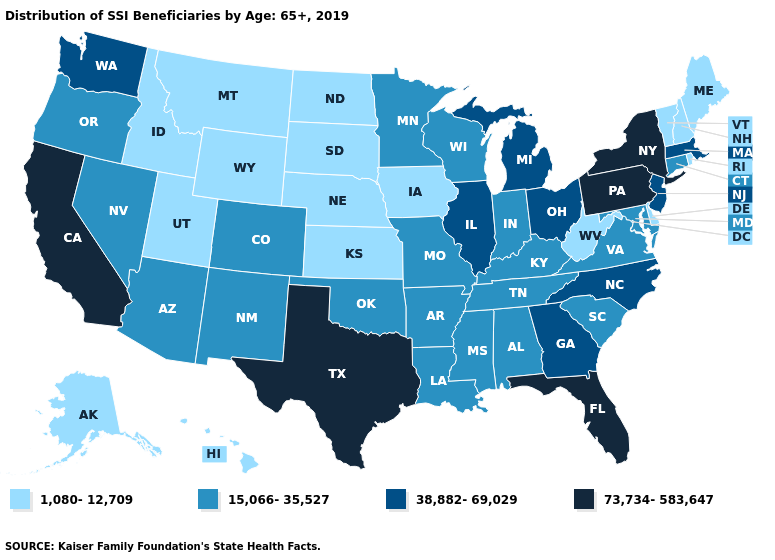Name the states that have a value in the range 38,882-69,029?
Short answer required. Georgia, Illinois, Massachusetts, Michigan, New Jersey, North Carolina, Ohio, Washington. Does the map have missing data?
Concise answer only. No. What is the value of Oregon?
Keep it brief. 15,066-35,527. Name the states that have a value in the range 1,080-12,709?
Write a very short answer. Alaska, Delaware, Hawaii, Idaho, Iowa, Kansas, Maine, Montana, Nebraska, New Hampshire, North Dakota, Rhode Island, South Dakota, Utah, Vermont, West Virginia, Wyoming. Does Wyoming have the same value as Iowa?
Answer briefly. Yes. Does the first symbol in the legend represent the smallest category?
Concise answer only. Yes. Does South Dakota have a lower value than Louisiana?
Quick response, please. Yes. What is the value of Massachusetts?
Give a very brief answer. 38,882-69,029. What is the value of Indiana?
Concise answer only. 15,066-35,527. Does Massachusetts have the lowest value in the Northeast?
Concise answer only. No. Does Maryland have a lower value than Texas?
Keep it brief. Yes. Which states have the lowest value in the USA?
Quick response, please. Alaska, Delaware, Hawaii, Idaho, Iowa, Kansas, Maine, Montana, Nebraska, New Hampshire, North Dakota, Rhode Island, South Dakota, Utah, Vermont, West Virginia, Wyoming. Among the states that border Nebraska , which have the lowest value?
Short answer required. Iowa, Kansas, South Dakota, Wyoming. How many symbols are there in the legend?
Be succinct. 4. Is the legend a continuous bar?
Quick response, please. No. 